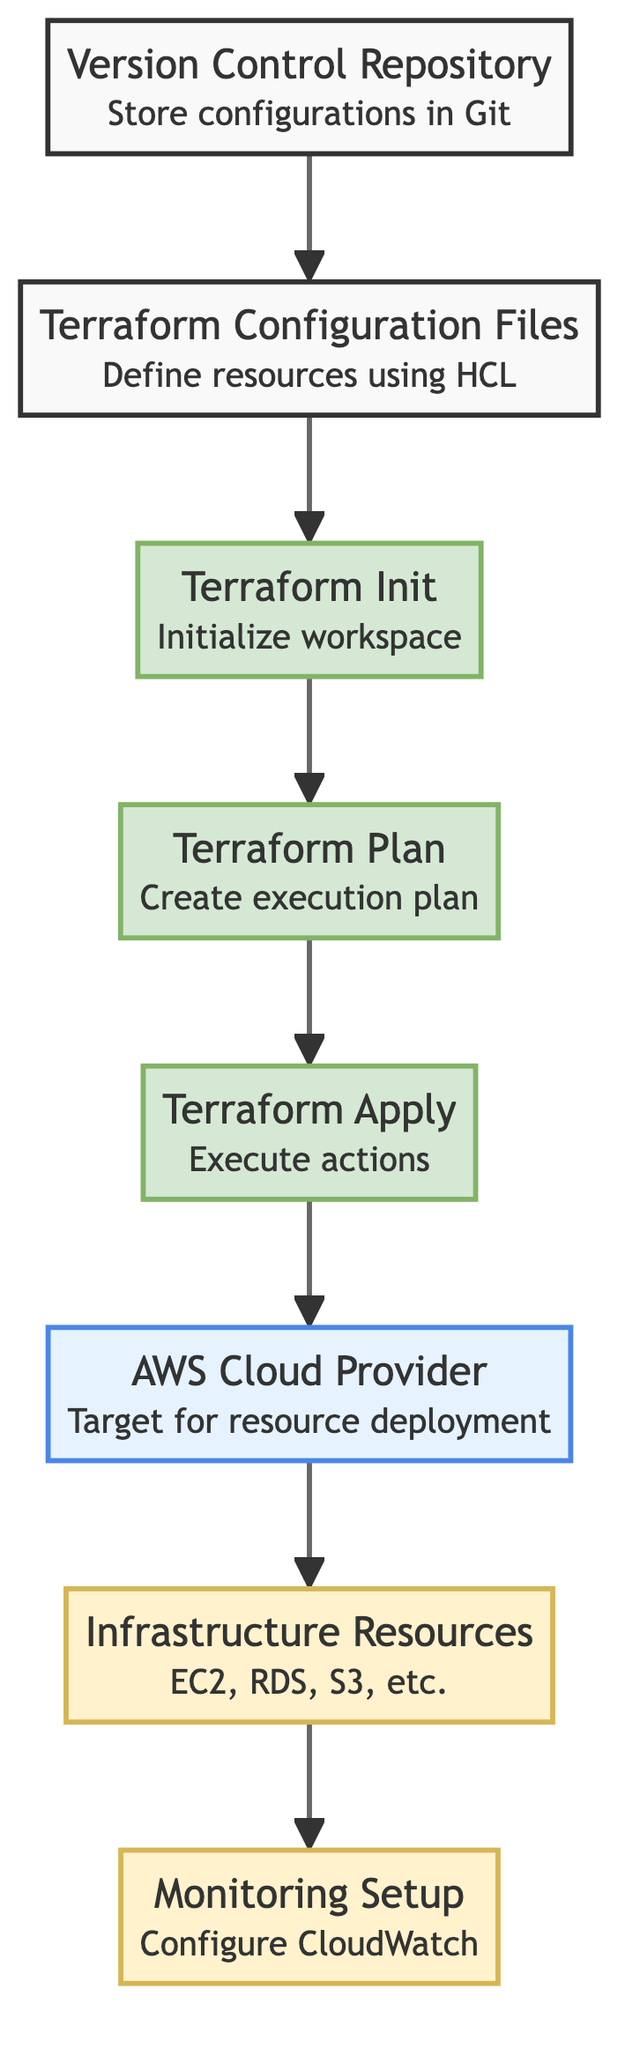What is the starting node of the flow chart? The flow chart starts with the "Terraform Configuration Files" node, indicating the beginning of the cloud infrastructure deployment process using Terraform.
Answer: Terraform Configuration Files How many nodes are in the flow chart? By counting all distinct elements in the flow chart, there are eight nodes that represent different steps and resources in the deployment process.
Answer: 8 What is the final node in the deployment process? The final node of the flow chart is "Monitoring Setup," which indicates the last step in the process where monitoring services are configured.
Answer: Monitoring Setup What is the relationship between "Terraform Apply" and "Cloud Provider"? "Terraform Apply" leads to "Cloud Provider," meaning that executing the proposed actions in the plan directly results in the choice of cloud provider for resource deployment.
Answer: leads to Which node provides the definition of resources required for the web application? The "Terraform Configuration Files" node defines the resources required for deploying the web application by using HashiCorp Configuration Language.
Answer: Terraform Configuration Files What is the purpose of the "Version Control Repository" in the deployment process? The "Version Control Repository" is used to store Terraform configurations, facilitating collaboration and versioning among team members during the deployment process.
Answer: Store Terraform configurations What node is configured after "Infrastructure Resources"? After "Infrastructure Resources," the next node is "Monitoring Setup," which involves setting up monitoring for the deployed infrastructure.
Answer: Monitoring Setup What type of resources are included in the "Infrastructure Resources" node? The "Infrastructure Resources" node mentions EC2 instances, RDS databases, and S3 buckets as the types of AWS resources that will be provisioned during the deployment.
Answer: EC2, RDS, S3 What does the "Terraform Init" step prepare for? The "Terraform Init" step initializes the workspace and prepares it by downloading necessary provider plugins needed for the deployment process.
Answer: Initialize the workspace 